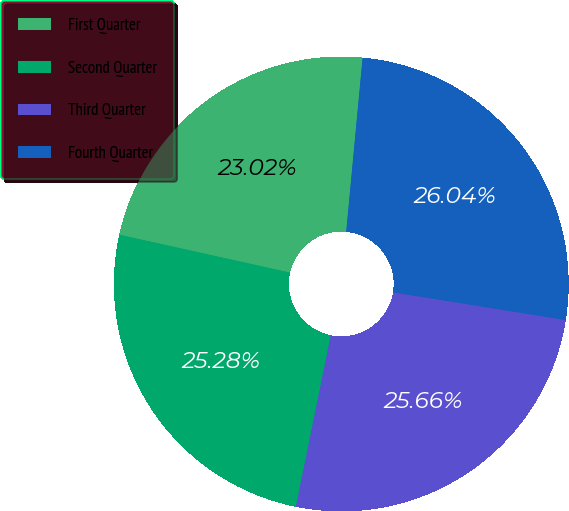<chart> <loc_0><loc_0><loc_500><loc_500><pie_chart><fcel>First Quarter<fcel>Second Quarter<fcel>Third Quarter<fcel>Fourth Quarter<nl><fcel>23.02%<fcel>25.28%<fcel>25.66%<fcel>26.04%<nl></chart> 